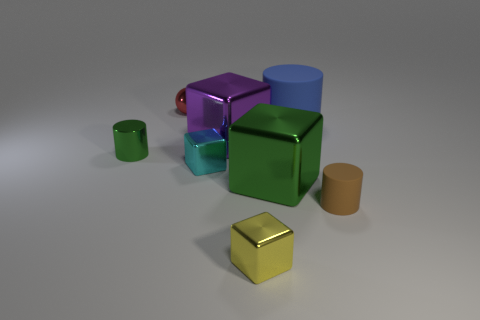The green shiny object that is on the left side of the tiny metallic block that is behind the big cube that is right of the purple cube is what shape?
Provide a short and direct response. Cylinder. There is a large thing that is in front of the purple shiny block; is its shape the same as the matte object behind the tiny green metallic cylinder?
Offer a very short reply. No. How many other objects are the same material as the purple thing?
Offer a terse response. 5. There is a yellow object that is the same material as the purple block; what is its shape?
Ensure brevity in your answer.  Cube. Do the red sphere and the purple shiny object have the same size?
Give a very brief answer. No. There is a green metal thing on the right side of the cylinder that is to the left of the big blue matte cylinder; how big is it?
Your answer should be compact. Large. What is the shape of the object that is the same color as the metal cylinder?
Your response must be concise. Cube. How many cylinders are large brown matte objects or tiny red things?
Make the answer very short. 0. There is a red thing; does it have the same size as the green metal thing that is left of the tiny yellow cube?
Keep it short and to the point. Yes. Are there more large objects that are on the left side of the big blue rubber cylinder than gray objects?
Give a very brief answer. Yes. 